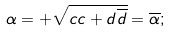Convert formula to latex. <formula><loc_0><loc_0><loc_500><loc_500>\alpha = + \sqrt { c c + d \overline { d } } = \overline { \alpha } ;</formula> 